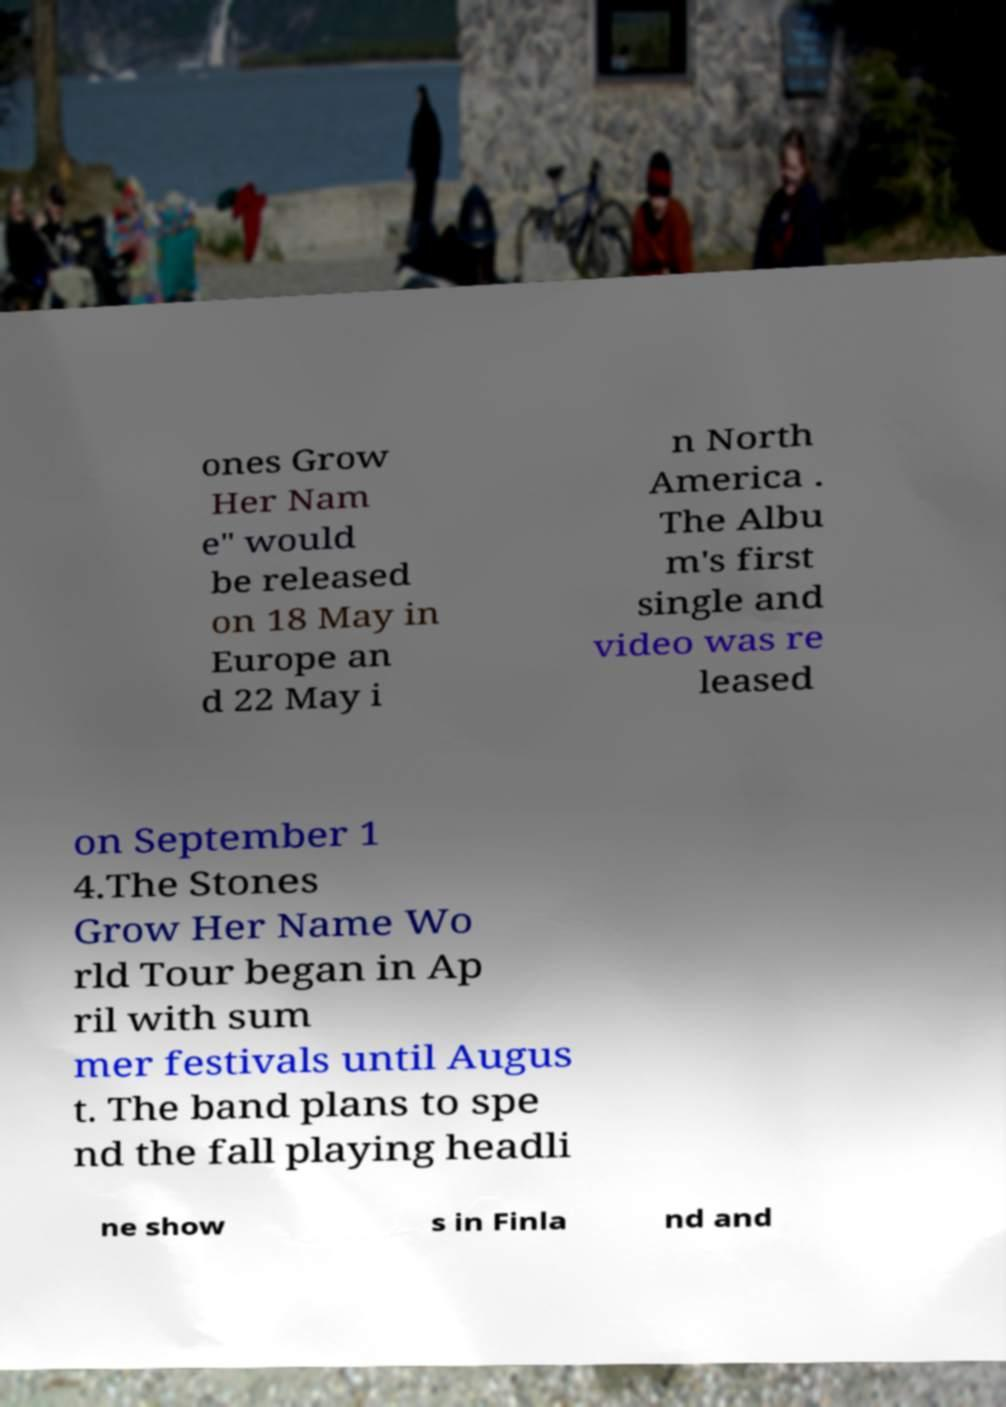Could you extract and type out the text from this image? ones Grow Her Nam e" would be released on 18 May in Europe an d 22 May i n North America . The Albu m's first single and video was re leased on September 1 4.The Stones Grow Her Name Wo rld Tour began in Ap ril with sum mer festivals until Augus t. The band plans to spe nd the fall playing headli ne show s in Finla nd and 